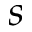<formula> <loc_0><loc_0><loc_500><loc_500>s</formula> 